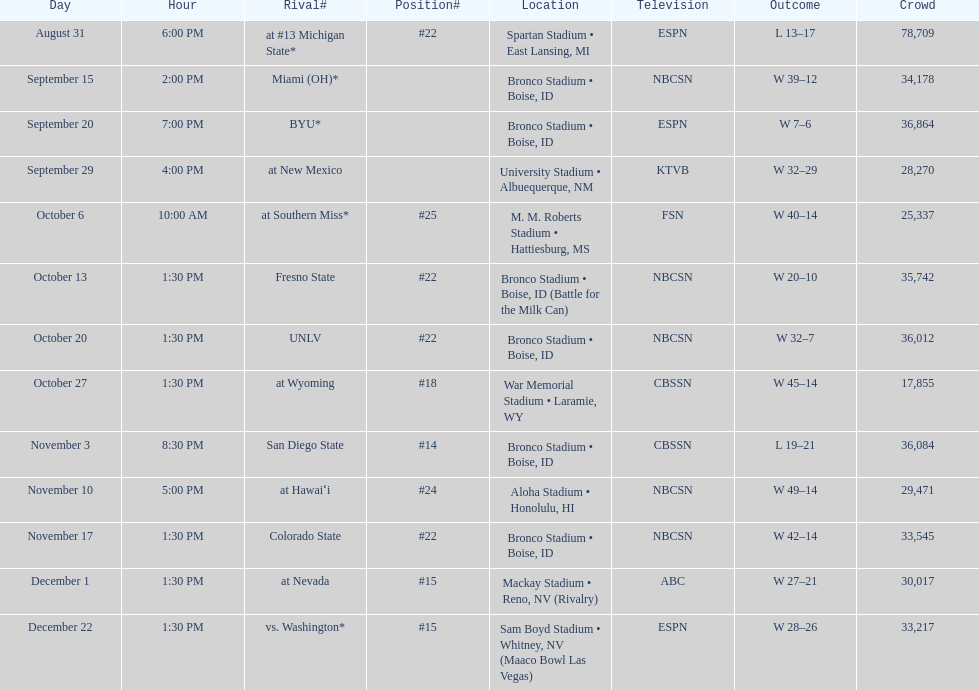Opponent broncos faced next after unlv Wyoming. 